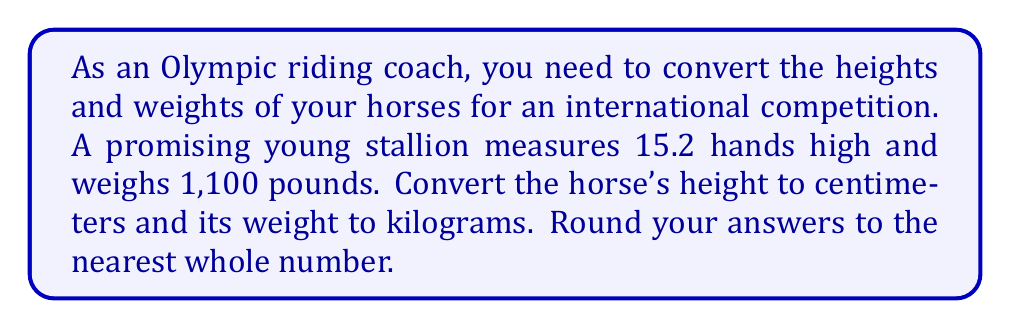Teach me how to tackle this problem. To solve this problem, we need to convert hands to centimeters for height and pounds to kilograms for weight.

1. Converting height from hands to centimeters:
   - 1 hand = 4 inches
   - 15.2 hands = 15 hands + 2 inches = (15 × 4) + 2 = 62 inches
   - To convert inches to centimeters, we multiply by 2.54
   
   $$ \text{Height in cm} = 62 \times 2.54 = 157.48 \text{ cm} $$

   Rounding to the nearest whole number: 157 cm

2. Converting weight from pounds to kilograms:
   - To convert pounds to kilograms, we divide by 2.20462
   
   $$ \text{Weight in kg} = \frac{1100}{2.20462} = 498.95 \text{ kg} $$

   Rounding to the nearest whole number: 499 kg
Answer: The horse's height is 157 cm, and its weight is 499 kg. 